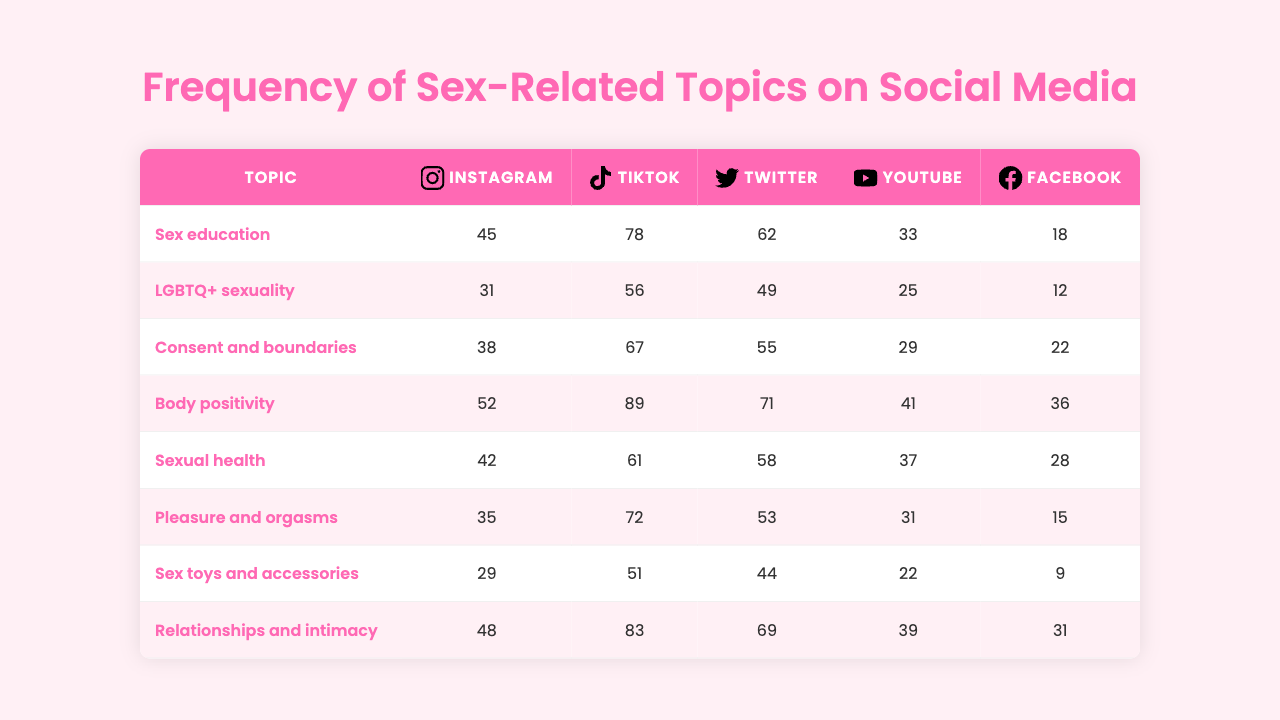What is the most discussed topic on Instagram? According to the table, the topic "Sex education" has the highest frequency on Instagram at 45.
Answer: 45 Which platform has the lowest mention of "Body positivity"? The table shows that Facebook has the lowest mention of "Body positivity" with a frequency of 28.
Answer: 28 What is the total frequency for "Sexual health" across all platforms? Adding the frequencies for "Sexual health": 18 (Instagram) + 12 (TikTok) + 22 (Twitter) + 36 (YouTube) + 28 (Facebook) gives 116.
Answer: 116 Which two platforms have the same frequency for "LGBTQ+ sexuality"? Looking at the data, TikTok and Facebook both have frequencies of 56, indicating they have the same amount for "LGBTQ+ sexuality".
Answer: Yes What is the average frequency for "Pleasure and orgasms" across all platforms? The frequencies for "Pleasure and orgasms" are 35 (Instagram), 31 (TikTok), 53 (Twitter), 41 (YouTube), and 39 (Facebook). Summing these gives 239, and dividing by 5 (the number of platforms) results in an average of 47.8.
Answer: 47.8 Which platform has the highest discussion frequency for "Relationships and intimacy"? According to the table, YouTube shows the highest frequency for "Relationships and intimacy" at 41.
Answer: 41 Is there a platform where the frequency of "Sex toys and accessories" is less than 30? The frequencies show that Facebook's frequency for "Sex toys and accessories" is 9, indicating that it is less than 30.
Answer: Yes What is the difference in frequency for "Consent and boundaries" between Twitter and Instagram? Looking at the frequencies, Twitter has 55 while Instagram has 62. The difference is calculated as 62 - 55, which equals 7.
Answer: 7 Which topic has the second highest overall frequency across all platforms? To find the second highest, sum the frequencies of each topic across platforms. After calculating, "Sex education" has 45+31+38+52+42=208, and "Pleasure and orgasms" follows with 35+31+53+41+39=239, hence "Pleasure and orgasms" is the answer.
Answer: 239 What proportion of the "Sex toys and accessories" mentions come from TikTok? TikTok's frequency for "Sex toys and accessories" is 31, and the total mentions across platforms for this topic is 144. The proportion is calculated as 31/144, which yields around 0.215 or 21.5%.
Answer: 21.5% 